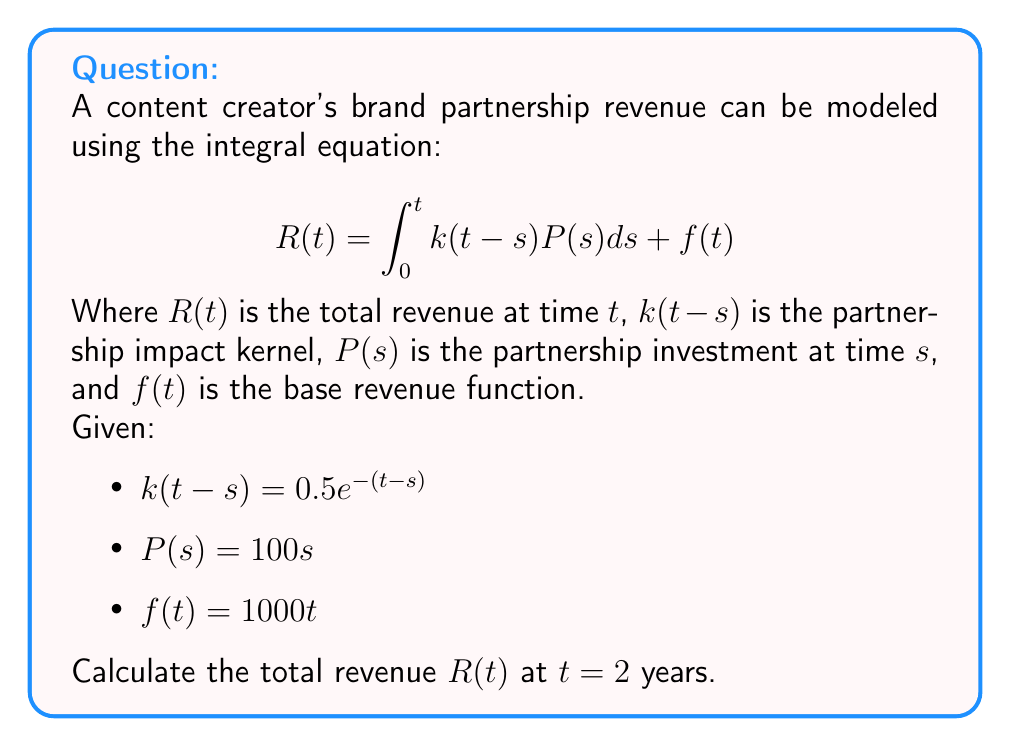Can you solve this math problem? To solve this problem, we'll follow these steps:

1) First, we need to substitute the given functions into the integral equation:

   $$R(2) = \int_0^2 0.5e^{-(2-s)}(100s)ds + 1000(2)$$

2) Let's focus on solving the integral part:

   $$\int_0^2 0.5e^{-(2-s)}(100s)ds = 50\int_0^2 se^{-(2-s)}ds$$

3) To solve this integral, we can use integration by parts. Let $u = s$ and $dv = e^{-(2-s)}ds$:

   $$50\left[-se^{-(2-s)}\right]_0^2 + 50\int_0^2 e^{-(2-s)}ds$$

4) Evaluating the first part:

   $$50\left[-2e^{-(2-2)} + 0e^{-(2-0)}\right] + 50\int_0^2 e^{-(2-s)}ds$$
   $$= -100 + 50\int_0^2 e^{-(2-s)}ds$$

5) Now, let's solve the remaining integral:

   $$50\int_0^2 e^{-(2-s)}ds = 50\left[-e^{-(2-s)}\right]_0^2 = 50\left[-1 + e^{-2}\right]$$

6) Combining the results from steps 4 and 5:

   $$-100 + 50\left[-1 + e^{-2}\right] = -150 + 50e^{-2}$$

7) Now, we add this result to the base revenue function $f(2) = 1000(2) = 2000$:

   $$R(2) = (-150 + 50e^{-2}) + 2000 = 1850 + 50e^{-2}$$

8) Evaluating $e^{-2} \approx 0.1353$:

   $$R(2) \approx 1850 + 50(0.1353) \approx 1856.77$$
Answer: $1856.77 